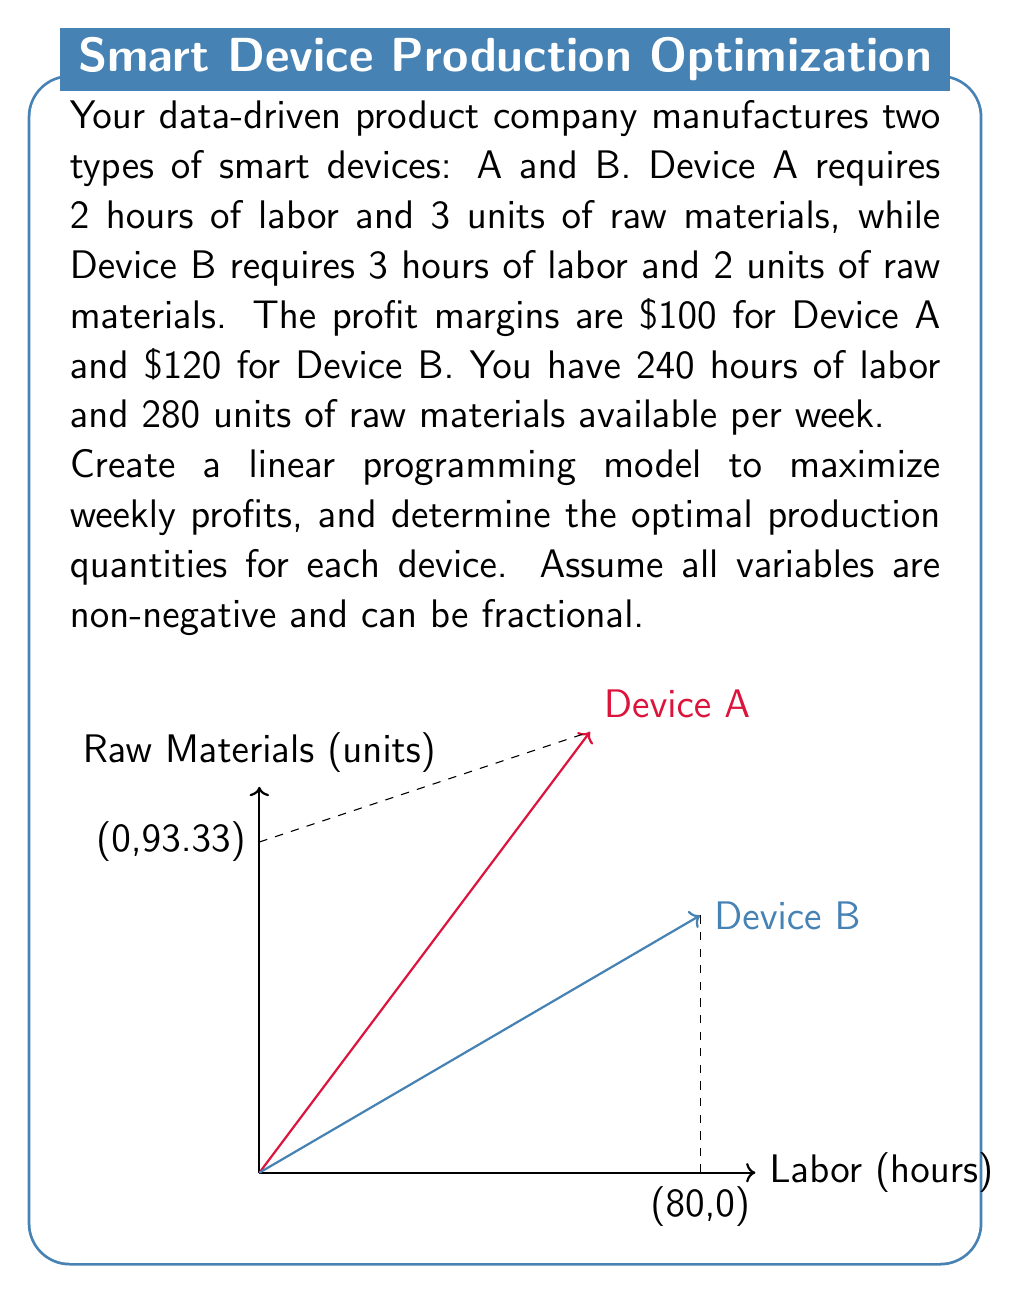Help me with this question. Let's approach this step-by-step:

1) Define variables:
   Let $x$ = number of Device A produced
   Let $y$ = number of Device B produced

2) Objective function (maximize profit):
   $$\text{Maximize } Z = 100x + 120y$$

3) Constraints:
   Labor constraint: $2x + 3y \leq 240$
   Raw materials constraint: $3x + 2y \leq 280$
   Non-negativity: $x \geq 0, y \geq 0$

4) To solve this graphically, we plot the constraints:
   Labor: $y = 80 - \frac{2}{3}x$
   Raw materials: $y = 140 - \frac{3}{2}x$

5) The feasible region is bounded by these lines and the axes.

6) The optimal solution will be at one of the corner points. We can find these by solving the equations simultaneously:

   $80 - \frac{2}{3}x = 140 - \frac{3}{2}x$
   $-60 = -\frac{5}{6}x$
   $x = 72$

   Substituting back:
   $y = 80 - \frac{2}{3}(72) = 32$

7) The corner points are (0,0), (0,80), (72,32), and (93.33,0).

8) Evaluate the objective function at each point:
   (0,0): Z = 0
   (0,80): Z = 9,600
   (72,32): Z = 10,960
   (93.33,0): Z = 9,333

9) The maximum profit occurs at (72,32).

Therefore, the optimal production schedule is to produce 72 units of Device A and 32 units of Device B per week, resulting in a maximum profit of $10,960.
Answer: Produce 72 Device A and 32 Device B for $10,960 weekly profit. 